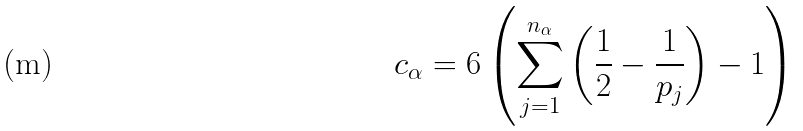<formula> <loc_0><loc_0><loc_500><loc_500>c _ { \alpha } = 6 \left ( \sum _ { j = 1 } ^ { n _ { \alpha } } \left ( \frac { 1 } { 2 } - \frac { 1 } { p _ { j } } \right ) - 1 \right )</formula> 